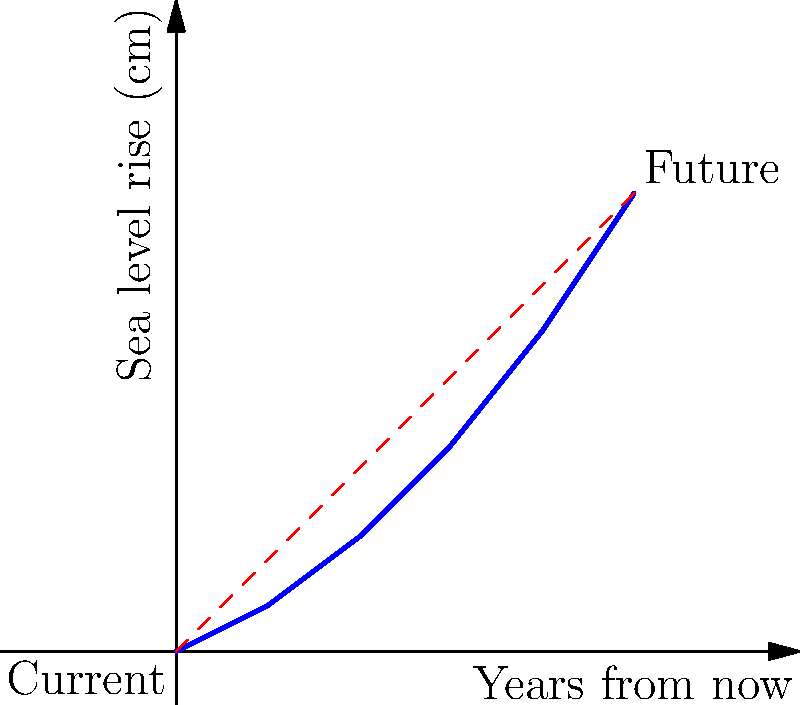A map shows the projected sea level rise over the next 100 years. The current sea level is marked at (0,0) cm, and the projected level after 100 years is at (100,100) cm. If you want to create a smaller version of this map that fits on a page 25 cm wide, what would be the coordinates of the future sea level point on this scaled-down version? Round your answer to the nearest whole number. To solve this problem, we need to use the concept of scaling in transformational geometry. Let's approach this step-by-step:

1) The original map spans from 0 to 100 cm in both x and y directions.

2) We want to scale it down to fit a 25 cm wide page. This means we need to find the scale factor.

3) Scale factor = New width / Original width
   $\text{Scale factor} = \frac{25 \text{ cm}}{100 \text{ cm}} = 0.25$

4) This scale factor applies to both x and y coordinates.

5) For the future sea level point:
   Original coordinates: (100, 100)
   
   New x-coordinate: $100 \times 0.25 = 25$
   New y-coordinate: $100 \times 0.25 = 25$

6) Therefore, the new coordinates are (25, 25).

7) The question asks to round to the nearest whole number, but 25 is already a whole number, so no rounding is necessary.

This scaled-down version maintains the same proportions as the original map, allowing for accurate representation of the projected sea level rise in a more compact format.
Answer: (25, 25) 